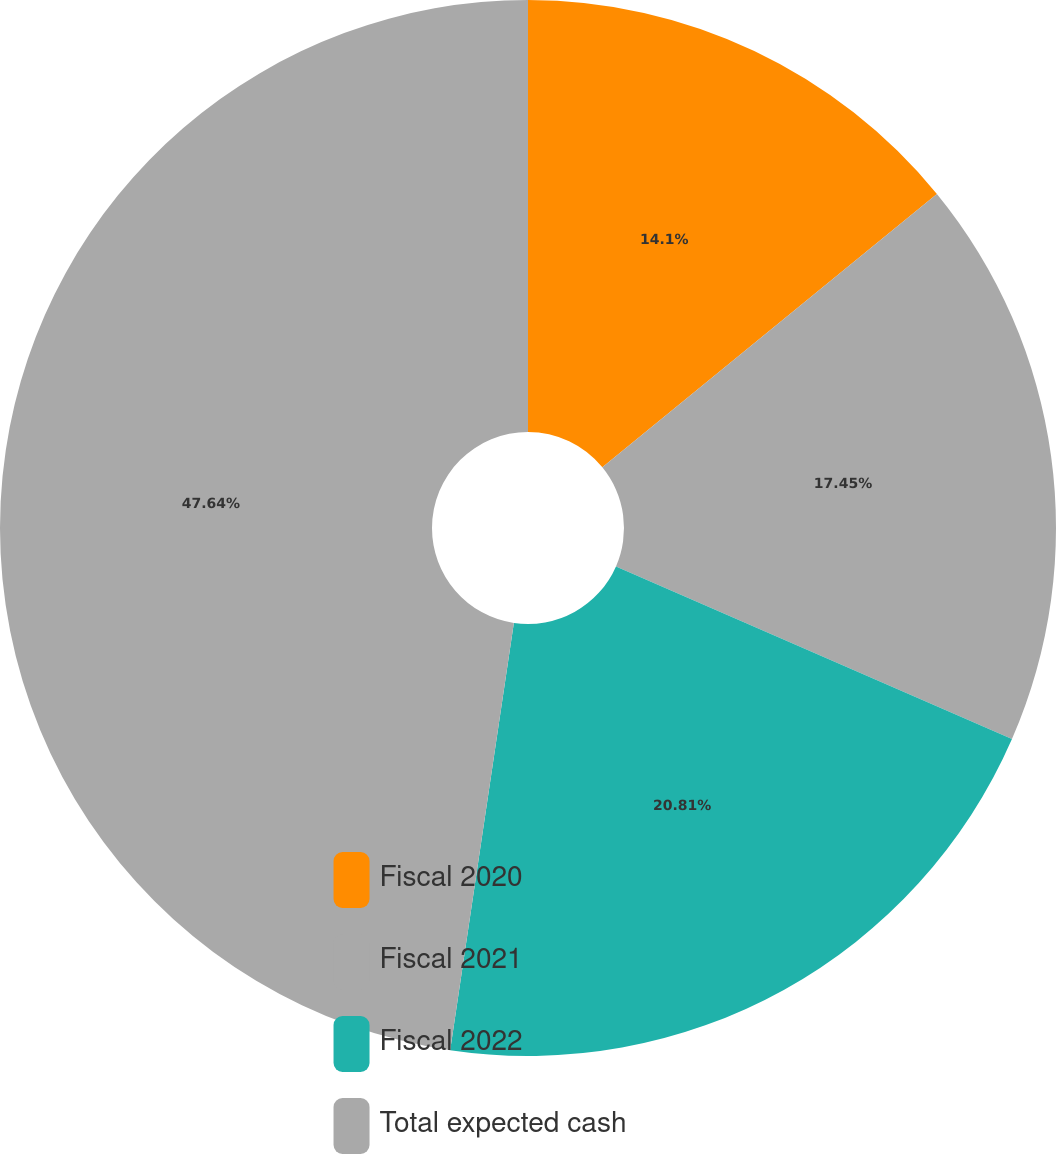Convert chart. <chart><loc_0><loc_0><loc_500><loc_500><pie_chart><fcel>Fiscal 2020<fcel>Fiscal 2021<fcel>Fiscal 2022<fcel>Total expected cash<nl><fcel>14.1%<fcel>17.45%<fcel>20.81%<fcel>47.65%<nl></chart> 